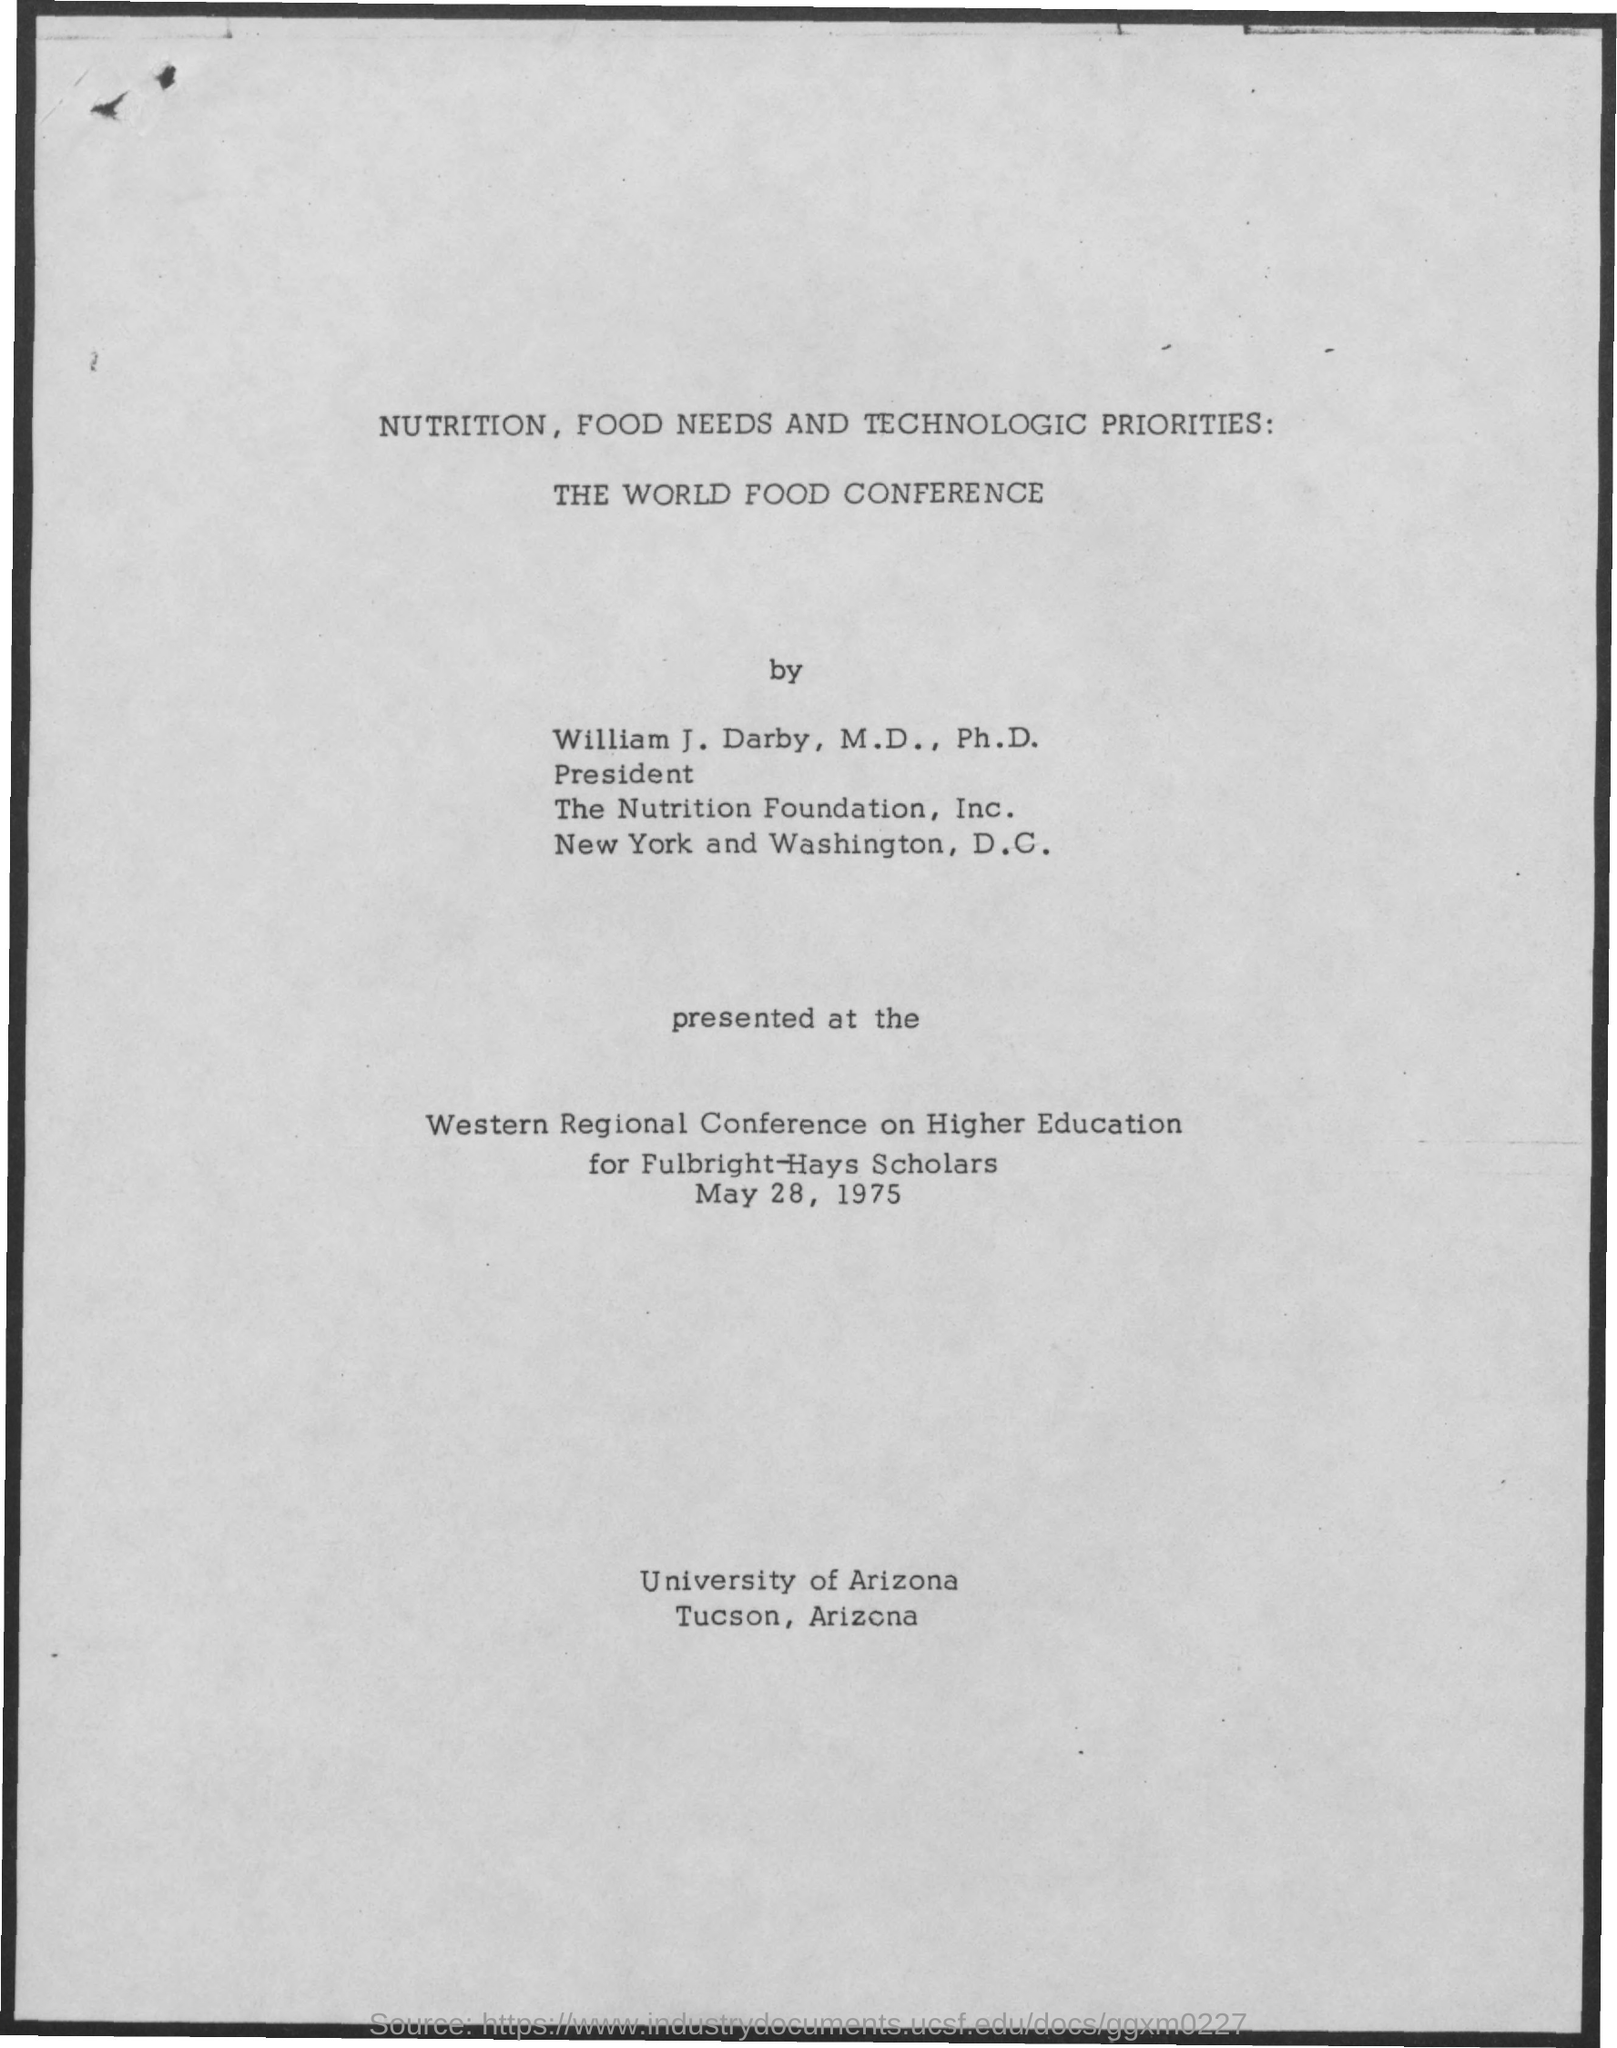Who was the Western regional conference on Higher Education for?
Offer a terse response. Fulbright-Hays scholars. When was the Western regional conference on Higher Education?
Keep it short and to the point. May 28, 1975. 